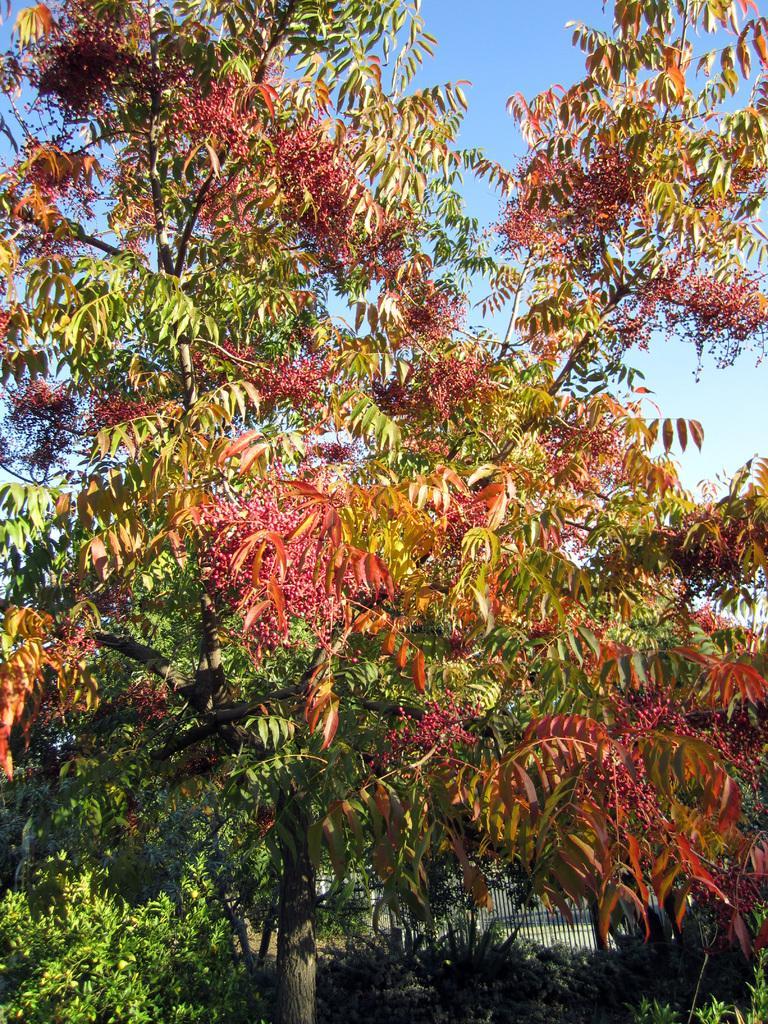Can you describe this image briefly? In this image we can see the trees, shrubs and the sky in the background. 